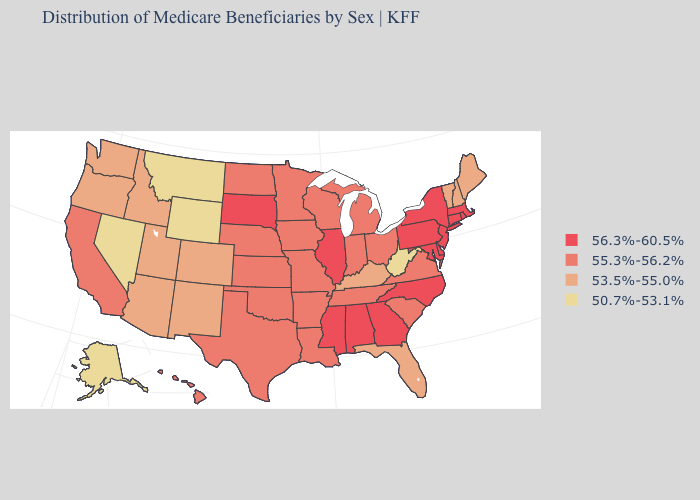What is the highest value in states that border Maryland?
Write a very short answer. 56.3%-60.5%. Which states hav the highest value in the South?
Short answer required. Alabama, Delaware, Georgia, Maryland, Mississippi, North Carolina. Which states hav the highest value in the Northeast?
Give a very brief answer. Connecticut, Massachusetts, New Jersey, New York, Pennsylvania, Rhode Island. What is the lowest value in the USA?
Be succinct. 50.7%-53.1%. Name the states that have a value in the range 56.3%-60.5%?
Keep it brief. Alabama, Connecticut, Delaware, Georgia, Illinois, Maryland, Massachusetts, Mississippi, New Jersey, New York, North Carolina, Pennsylvania, Rhode Island, South Dakota. Name the states that have a value in the range 56.3%-60.5%?
Be succinct. Alabama, Connecticut, Delaware, Georgia, Illinois, Maryland, Massachusetts, Mississippi, New Jersey, New York, North Carolina, Pennsylvania, Rhode Island, South Dakota. What is the highest value in the MidWest ?
Quick response, please. 56.3%-60.5%. What is the highest value in states that border Massachusetts?
Concise answer only. 56.3%-60.5%. What is the lowest value in states that border New Mexico?
Concise answer only. 53.5%-55.0%. What is the value of Colorado?
Write a very short answer. 53.5%-55.0%. What is the value of Massachusetts?
Quick response, please. 56.3%-60.5%. Does South Carolina have a lower value than Nevada?
Quick response, please. No. Does New Mexico have a higher value than Tennessee?
Short answer required. No. Which states hav the highest value in the Northeast?
Give a very brief answer. Connecticut, Massachusetts, New Jersey, New York, Pennsylvania, Rhode Island. How many symbols are there in the legend?
Write a very short answer. 4. 